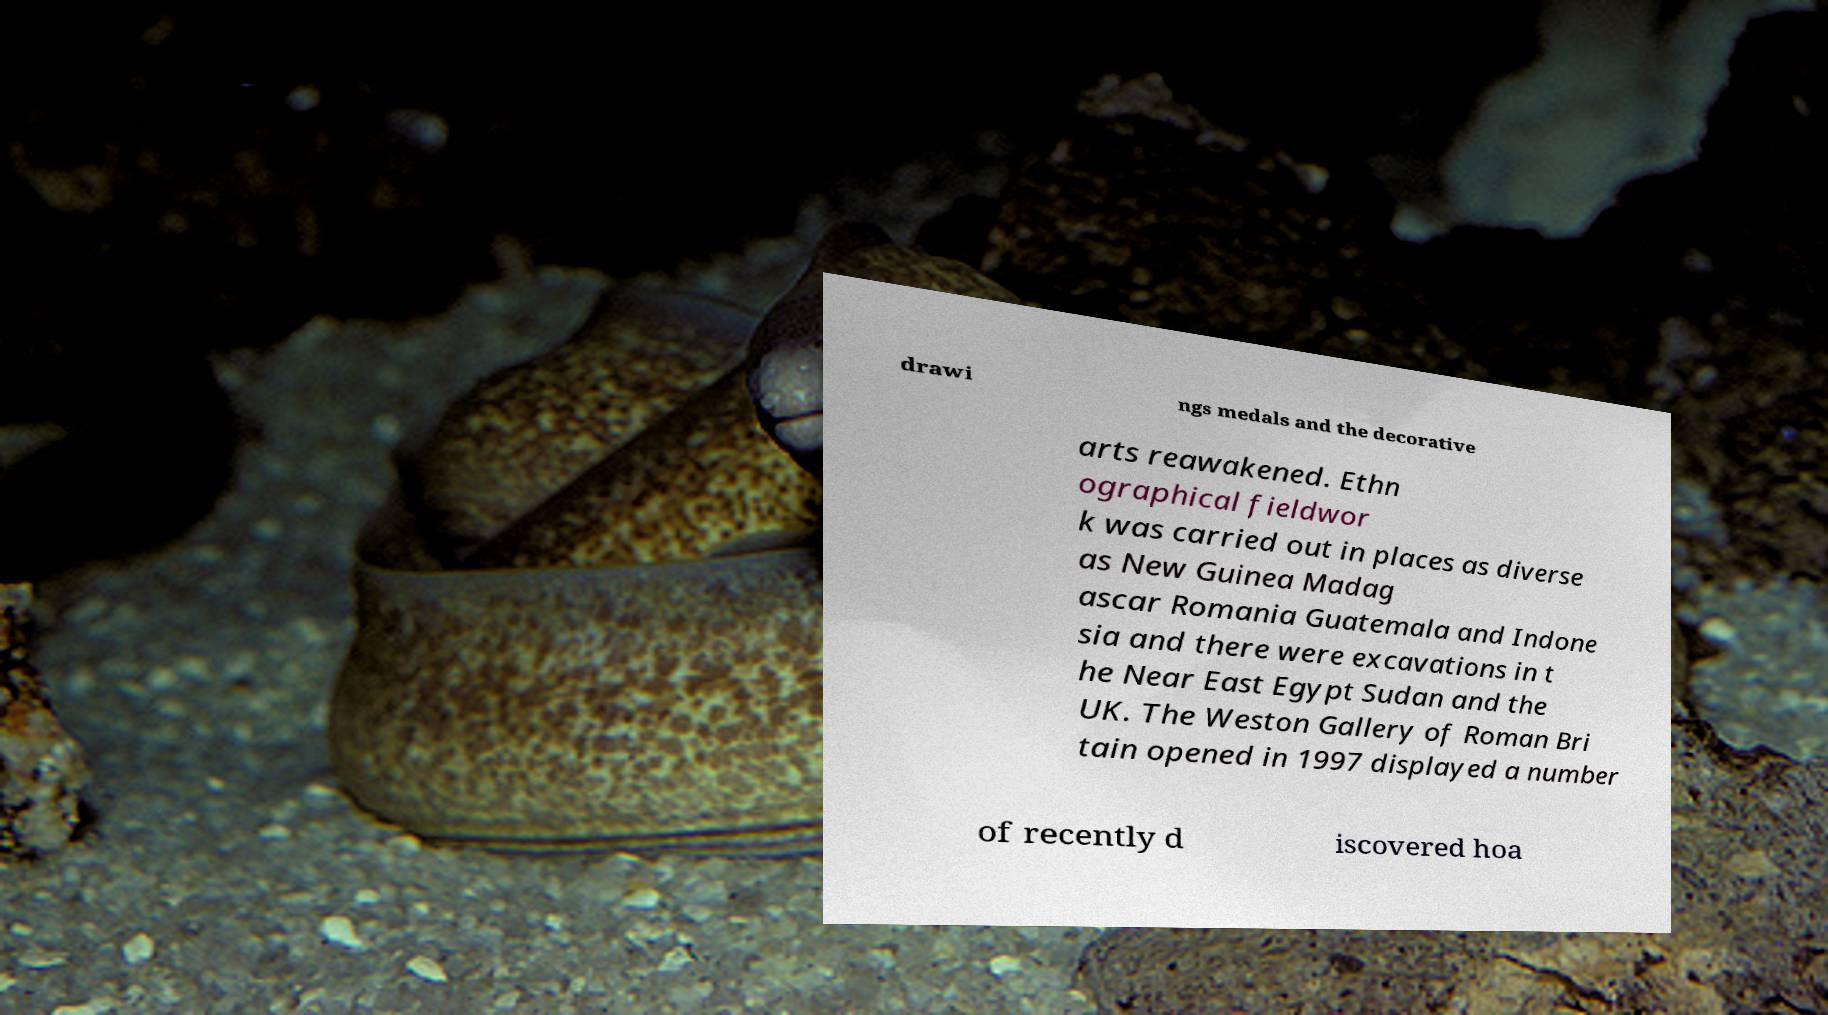I need the written content from this picture converted into text. Can you do that? drawi ngs medals and the decorative arts reawakened. Ethn ographical fieldwor k was carried out in places as diverse as New Guinea Madag ascar Romania Guatemala and Indone sia and there were excavations in t he Near East Egypt Sudan and the UK. The Weston Gallery of Roman Bri tain opened in 1997 displayed a number of recently d iscovered hoa 